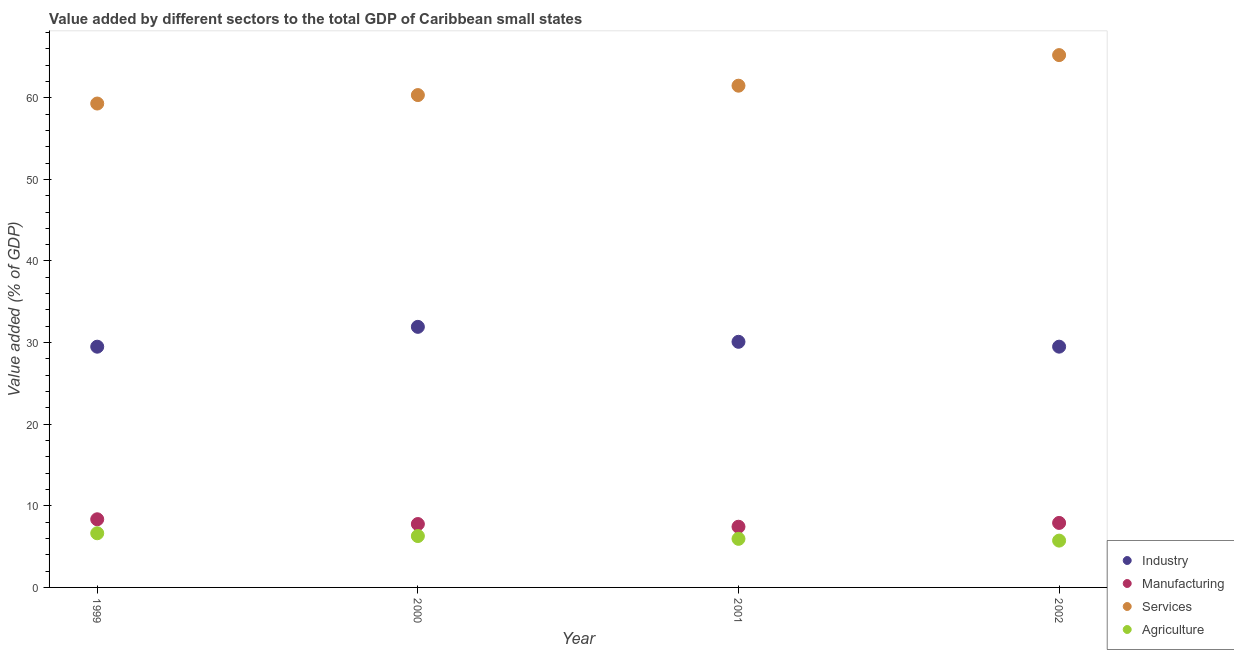How many different coloured dotlines are there?
Provide a short and direct response. 4. Is the number of dotlines equal to the number of legend labels?
Your answer should be very brief. Yes. What is the value added by industrial sector in 2001?
Make the answer very short. 30.1. Across all years, what is the maximum value added by manufacturing sector?
Ensure brevity in your answer.  8.35. Across all years, what is the minimum value added by manufacturing sector?
Provide a succinct answer. 7.44. What is the total value added by industrial sector in the graph?
Provide a short and direct response. 121.03. What is the difference between the value added by agricultural sector in 1999 and that in 2001?
Your response must be concise. 0.68. What is the difference between the value added by services sector in 2001 and the value added by agricultural sector in 1999?
Your answer should be very brief. 54.84. What is the average value added by services sector per year?
Your answer should be very brief. 61.58. In the year 1999, what is the difference between the value added by manufacturing sector and value added by industrial sector?
Your answer should be very brief. -21.15. In how many years, is the value added by agricultural sector greater than 46 %?
Offer a very short reply. 0. What is the ratio of the value added by services sector in 2000 to that in 2001?
Your answer should be very brief. 0.98. Is the value added by manufacturing sector in 2000 less than that in 2001?
Your response must be concise. No. Is the difference between the value added by manufacturing sector in 1999 and 2002 greater than the difference between the value added by industrial sector in 1999 and 2002?
Your answer should be very brief. Yes. What is the difference between the highest and the second highest value added by agricultural sector?
Offer a very short reply. 0.34. What is the difference between the highest and the lowest value added by agricultural sector?
Provide a short and direct response. 0.9. In how many years, is the value added by industrial sector greater than the average value added by industrial sector taken over all years?
Provide a succinct answer. 1. Is it the case that in every year, the sum of the value added by services sector and value added by agricultural sector is greater than the sum of value added by industrial sector and value added by manufacturing sector?
Your answer should be compact. Yes. Is the value added by services sector strictly greater than the value added by agricultural sector over the years?
Your answer should be very brief. Yes. Is the value added by agricultural sector strictly less than the value added by industrial sector over the years?
Your answer should be compact. Yes. How many dotlines are there?
Your answer should be compact. 4. Are the values on the major ticks of Y-axis written in scientific E-notation?
Your answer should be very brief. No. Does the graph contain any zero values?
Your answer should be very brief. No. Does the graph contain grids?
Your answer should be compact. No. What is the title of the graph?
Keep it short and to the point. Value added by different sectors to the total GDP of Caribbean small states. Does "Taxes on income" appear as one of the legend labels in the graph?
Your response must be concise. No. What is the label or title of the Y-axis?
Keep it short and to the point. Value added (% of GDP). What is the Value added (% of GDP) in Industry in 1999?
Your answer should be very brief. 29.5. What is the Value added (% of GDP) in Manufacturing in 1999?
Provide a short and direct response. 8.35. What is the Value added (% of GDP) in Services in 1999?
Keep it short and to the point. 59.29. What is the Value added (% of GDP) in Agriculture in 1999?
Your answer should be very brief. 6.64. What is the Value added (% of GDP) of Industry in 2000?
Your answer should be compact. 31.93. What is the Value added (% of GDP) in Manufacturing in 2000?
Your response must be concise. 7.77. What is the Value added (% of GDP) in Services in 2000?
Ensure brevity in your answer.  60.33. What is the Value added (% of GDP) of Agriculture in 2000?
Your answer should be compact. 6.3. What is the Value added (% of GDP) of Industry in 2001?
Your response must be concise. 30.1. What is the Value added (% of GDP) of Manufacturing in 2001?
Make the answer very short. 7.44. What is the Value added (% of GDP) of Services in 2001?
Provide a short and direct response. 61.48. What is the Value added (% of GDP) in Agriculture in 2001?
Make the answer very short. 5.95. What is the Value added (% of GDP) in Industry in 2002?
Offer a very short reply. 29.5. What is the Value added (% of GDP) of Manufacturing in 2002?
Your answer should be very brief. 7.9. What is the Value added (% of GDP) in Services in 2002?
Make the answer very short. 65.23. What is the Value added (% of GDP) in Agriculture in 2002?
Provide a short and direct response. 5.74. Across all years, what is the maximum Value added (% of GDP) of Industry?
Keep it short and to the point. 31.93. Across all years, what is the maximum Value added (% of GDP) in Manufacturing?
Keep it short and to the point. 8.35. Across all years, what is the maximum Value added (% of GDP) in Services?
Provide a succinct answer. 65.23. Across all years, what is the maximum Value added (% of GDP) in Agriculture?
Provide a succinct answer. 6.64. Across all years, what is the minimum Value added (% of GDP) in Industry?
Provide a short and direct response. 29.5. Across all years, what is the minimum Value added (% of GDP) in Manufacturing?
Provide a succinct answer. 7.44. Across all years, what is the minimum Value added (% of GDP) of Services?
Make the answer very short. 59.29. Across all years, what is the minimum Value added (% of GDP) of Agriculture?
Give a very brief answer. 5.74. What is the total Value added (% of GDP) of Industry in the graph?
Provide a succinct answer. 121.03. What is the total Value added (% of GDP) in Manufacturing in the graph?
Your response must be concise. 31.46. What is the total Value added (% of GDP) of Services in the graph?
Offer a very short reply. 246.33. What is the total Value added (% of GDP) of Agriculture in the graph?
Your answer should be compact. 24.62. What is the difference between the Value added (% of GDP) in Industry in 1999 and that in 2000?
Offer a very short reply. -2.43. What is the difference between the Value added (% of GDP) in Manufacturing in 1999 and that in 2000?
Make the answer very short. 0.58. What is the difference between the Value added (% of GDP) of Services in 1999 and that in 2000?
Provide a succinct answer. -1.04. What is the difference between the Value added (% of GDP) of Agriculture in 1999 and that in 2000?
Offer a terse response. 0.34. What is the difference between the Value added (% of GDP) in Industry in 1999 and that in 2001?
Offer a very short reply. -0.6. What is the difference between the Value added (% of GDP) in Manufacturing in 1999 and that in 2001?
Provide a short and direct response. 0.91. What is the difference between the Value added (% of GDP) of Services in 1999 and that in 2001?
Offer a very short reply. -2.19. What is the difference between the Value added (% of GDP) in Agriculture in 1999 and that in 2001?
Make the answer very short. 0.68. What is the difference between the Value added (% of GDP) in Industry in 1999 and that in 2002?
Your answer should be compact. -0. What is the difference between the Value added (% of GDP) of Manufacturing in 1999 and that in 2002?
Your answer should be very brief. 0.45. What is the difference between the Value added (% of GDP) of Services in 1999 and that in 2002?
Make the answer very short. -5.93. What is the difference between the Value added (% of GDP) in Agriculture in 1999 and that in 2002?
Your answer should be very brief. 0.9. What is the difference between the Value added (% of GDP) of Industry in 2000 and that in 2001?
Your response must be concise. 1.83. What is the difference between the Value added (% of GDP) of Manufacturing in 2000 and that in 2001?
Your answer should be compact. 0.33. What is the difference between the Value added (% of GDP) in Services in 2000 and that in 2001?
Offer a terse response. -1.15. What is the difference between the Value added (% of GDP) of Agriculture in 2000 and that in 2001?
Offer a terse response. 0.34. What is the difference between the Value added (% of GDP) in Industry in 2000 and that in 2002?
Your answer should be very brief. 2.43. What is the difference between the Value added (% of GDP) in Manufacturing in 2000 and that in 2002?
Provide a short and direct response. -0.14. What is the difference between the Value added (% of GDP) in Services in 2000 and that in 2002?
Give a very brief answer. -4.9. What is the difference between the Value added (% of GDP) of Agriculture in 2000 and that in 2002?
Your response must be concise. 0.56. What is the difference between the Value added (% of GDP) in Industry in 2001 and that in 2002?
Provide a succinct answer. 0.59. What is the difference between the Value added (% of GDP) in Manufacturing in 2001 and that in 2002?
Give a very brief answer. -0.47. What is the difference between the Value added (% of GDP) in Services in 2001 and that in 2002?
Offer a terse response. -3.75. What is the difference between the Value added (% of GDP) in Agriculture in 2001 and that in 2002?
Give a very brief answer. 0.22. What is the difference between the Value added (% of GDP) in Industry in 1999 and the Value added (% of GDP) in Manufacturing in 2000?
Ensure brevity in your answer.  21.73. What is the difference between the Value added (% of GDP) of Industry in 1999 and the Value added (% of GDP) of Services in 2000?
Your answer should be compact. -30.83. What is the difference between the Value added (% of GDP) of Industry in 1999 and the Value added (% of GDP) of Agriculture in 2000?
Offer a terse response. 23.2. What is the difference between the Value added (% of GDP) in Manufacturing in 1999 and the Value added (% of GDP) in Services in 2000?
Give a very brief answer. -51.98. What is the difference between the Value added (% of GDP) of Manufacturing in 1999 and the Value added (% of GDP) of Agriculture in 2000?
Keep it short and to the point. 2.06. What is the difference between the Value added (% of GDP) of Services in 1999 and the Value added (% of GDP) of Agriculture in 2000?
Your answer should be compact. 53. What is the difference between the Value added (% of GDP) in Industry in 1999 and the Value added (% of GDP) in Manufacturing in 2001?
Your answer should be very brief. 22.06. What is the difference between the Value added (% of GDP) in Industry in 1999 and the Value added (% of GDP) in Services in 2001?
Make the answer very short. -31.98. What is the difference between the Value added (% of GDP) in Industry in 1999 and the Value added (% of GDP) in Agriculture in 2001?
Offer a terse response. 23.55. What is the difference between the Value added (% of GDP) of Manufacturing in 1999 and the Value added (% of GDP) of Services in 2001?
Your answer should be compact. -53.13. What is the difference between the Value added (% of GDP) of Manufacturing in 1999 and the Value added (% of GDP) of Agriculture in 2001?
Offer a very short reply. 2.4. What is the difference between the Value added (% of GDP) of Services in 1999 and the Value added (% of GDP) of Agriculture in 2001?
Ensure brevity in your answer.  53.34. What is the difference between the Value added (% of GDP) of Industry in 1999 and the Value added (% of GDP) of Manufacturing in 2002?
Give a very brief answer. 21.59. What is the difference between the Value added (% of GDP) in Industry in 1999 and the Value added (% of GDP) in Services in 2002?
Offer a terse response. -35.73. What is the difference between the Value added (% of GDP) of Industry in 1999 and the Value added (% of GDP) of Agriculture in 2002?
Offer a very short reply. 23.76. What is the difference between the Value added (% of GDP) in Manufacturing in 1999 and the Value added (% of GDP) in Services in 2002?
Offer a very short reply. -56.88. What is the difference between the Value added (% of GDP) of Manufacturing in 1999 and the Value added (% of GDP) of Agriculture in 2002?
Your answer should be compact. 2.62. What is the difference between the Value added (% of GDP) of Services in 1999 and the Value added (% of GDP) of Agriculture in 2002?
Ensure brevity in your answer.  53.56. What is the difference between the Value added (% of GDP) in Industry in 2000 and the Value added (% of GDP) in Manufacturing in 2001?
Offer a very short reply. 24.49. What is the difference between the Value added (% of GDP) in Industry in 2000 and the Value added (% of GDP) in Services in 2001?
Make the answer very short. -29.55. What is the difference between the Value added (% of GDP) in Industry in 2000 and the Value added (% of GDP) in Agriculture in 2001?
Make the answer very short. 25.98. What is the difference between the Value added (% of GDP) in Manufacturing in 2000 and the Value added (% of GDP) in Services in 2001?
Give a very brief answer. -53.71. What is the difference between the Value added (% of GDP) in Manufacturing in 2000 and the Value added (% of GDP) in Agriculture in 2001?
Your answer should be very brief. 1.81. What is the difference between the Value added (% of GDP) in Services in 2000 and the Value added (% of GDP) in Agriculture in 2001?
Your answer should be very brief. 54.38. What is the difference between the Value added (% of GDP) in Industry in 2000 and the Value added (% of GDP) in Manufacturing in 2002?
Ensure brevity in your answer.  24.03. What is the difference between the Value added (% of GDP) in Industry in 2000 and the Value added (% of GDP) in Services in 2002?
Give a very brief answer. -33.3. What is the difference between the Value added (% of GDP) of Industry in 2000 and the Value added (% of GDP) of Agriculture in 2002?
Offer a terse response. 26.19. What is the difference between the Value added (% of GDP) of Manufacturing in 2000 and the Value added (% of GDP) of Services in 2002?
Offer a terse response. -57.46. What is the difference between the Value added (% of GDP) of Manufacturing in 2000 and the Value added (% of GDP) of Agriculture in 2002?
Offer a terse response. 2.03. What is the difference between the Value added (% of GDP) in Services in 2000 and the Value added (% of GDP) in Agriculture in 2002?
Provide a succinct answer. 54.59. What is the difference between the Value added (% of GDP) of Industry in 2001 and the Value added (% of GDP) of Manufacturing in 2002?
Offer a very short reply. 22.19. What is the difference between the Value added (% of GDP) in Industry in 2001 and the Value added (% of GDP) in Services in 2002?
Your answer should be very brief. -35.13. What is the difference between the Value added (% of GDP) of Industry in 2001 and the Value added (% of GDP) of Agriculture in 2002?
Your response must be concise. 24.36. What is the difference between the Value added (% of GDP) in Manufacturing in 2001 and the Value added (% of GDP) in Services in 2002?
Your answer should be compact. -57.79. What is the difference between the Value added (% of GDP) in Manufacturing in 2001 and the Value added (% of GDP) in Agriculture in 2002?
Give a very brief answer. 1.7. What is the difference between the Value added (% of GDP) in Services in 2001 and the Value added (% of GDP) in Agriculture in 2002?
Your response must be concise. 55.74. What is the average Value added (% of GDP) of Industry per year?
Offer a very short reply. 30.26. What is the average Value added (% of GDP) in Manufacturing per year?
Keep it short and to the point. 7.86. What is the average Value added (% of GDP) of Services per year?
Your response must be concise. 61.58. What is the average Value added (% of GDP) in Agriculture per year?
Offer a terse response. 6.16. In the year 1999, what is the difference between the Value added (% of GDP) of Industry and Value added (% of GDP) of Manufacturing?
Your answer should be very brief. 21.15. In the year 1999, what is the difference between the Value added (% of GDP) of Industry and Value added (% of GDP) of Services?
Your response must be concise. -29.79. In the year 1999, what is the difference between the Value added (% of GDP) in Industry and Value added (% of GDP) in Agriculture?
Your answer should be very brief. 22.86. In the year 1999, what is the difference between the Value added (% of GDP) in Manufacturing and Value added (% of GDP) in Services?
Your answer should be compact. -50.94. In the year 1999, what is the difference between the Value added (% of GDP) in Manufacturing and Value added (% of GDP) in Agriculture?
Provide a succinct answer. 1.71. In the year 1999, what is the difference between the Value added (% of GDP) of Services and Value added (% of GDP) of Agriculture?
Your response must be concise. 52.66. In the year 2000, what is the difference between the Value added (% of GDP) in Industry and Value added (% of GDP) in Manufacturing?
Keep it short and to the point. 24.16. In the year 2000, what is the difference between the Value added (% of GDP) in Industry and Value added (% of GDP) in Services?
Ensure brevity in your answer.  -28.4. In the year 2000, what is the difference between the Value added (% of GDP) in Industry and Value added (% of GDP) in Agriculture?
Provide a short and direct response. 25.63. In the year 2000, what is the difference between the Value added (% of GDP) of Manufacturing and Value added (% of GDP) of Services?
Ensure brevity in your answer.  -52.56. In the year 2000, what is the difference between the Value added (% of GDP) in Manufacturing and Value added (% of GDP) in Agriculture?
Provide a short and direct response. 1.47. In the year 2000, what is the difference between the Value added (% of GDP) of Services and Value added (% of GDP) of Agriculture?
Provide a short and direct response. 54.03. In the year 2001, what is the difference between the Value added (% of GDP) in Industry and Value added (% of GDP) in Manufacturing?
Give a very brief answer. 22.66. In the year 2001, what is the difference between the Value added (% of GDP) in Industry and Value added (% of GDP) in Services?
Keep it short and to the point. -31.38. In the year 2001, what is the difference between the Value added (% of GDP) in Industry and Value added (% of GDP) in Agriculture?
Offer a very short reply. 24.14. In the year 2001, what is the difference between the Value added (% of GDP) in Manufacturing and Value added (% of GDP) in Services?
Ensure brevity in your answer.  -54.04. In the year 2001, what is the difference between the Value added (% of GDP) of Manufacturing and Value added (% of GDP) of Agriculture?
Your answer should be compact. 1.48. In the year 2001, what is the difference between the Value added (% of GDP) of Services and Value added (% of GDP) of Agriculture?
Keep it short and to the point. 55.53. In the year 2002, what is the difference between the Value added (% of GDP) of Industry and Value added (% of GDP) of Manufacturing?
Your answer should be very brief. 21.6. In the year 2002, what is the difference between the Value added (% of GDP) in Industry and Value added (% of GDP) in Services?
Offer a terse response. -35.73. In the year 2002, what is the difference between the Value added (% of GDP) of Industry and Value added (% of GDP) of Agriculture?
Offer a terse response. 23.77. In the year 2002, what is the difference between the Value added (% of GDP) in Manufacturing and Value added (% of GDP) in Services?
Provide a succinct answer. -57.32. In the year 2002, what is the difference between the Value added (% of GDP) in Manufacturing and Value added (% of GDP) in Agriculture?
Offer a very short reply. 2.17. In the year 2002, what is the difference between the Value added (% of GDP) of Services and Value added (% of GDP) of Agriculture?
Keep it short and to the point. 59.49. What is the ratio of the Value added (% of GDP) in Industry in 1999 to that in 2000?
Your answer should be very brief. 0.92. What is the ratio of the Value added (% of GDP) of Manufacturing in 1999 to that in 2000?
Provide a succinct answer. 1.08. What is the ratio of the Value added (% of GDP) of Services in 1999 to that in 2000?
Offer a terse response. 0.98. What is the ratio of the Value added (% of GDP) of Agriculture in 1999 to that in 2000?
Provide a short and direct response. 1.05. What is the ratio of the Value added (% of GDP) in Industry in 1999 to that in 2001?
Your answer should be very brief. 0.98. What is the ratio of the Value added (% of GDP) in Manufacturing in 1999 to that in 2001?
Offer a very short reply. 1.12. What is the ratio of the Value added (% of GDP) in Services in 1999 to that in 2001?
Keep it short and to the point. 0.96. What is the ratio of the Value added (% of GDP) in Agriculture in 1999 to that in 2001?
Your answer should be compact. 1.11. What is the ratio of the Value added (% of GDP) of Industry in 1999 to that in 2002?
Make the answer very short. 1. What is the ratio of the Value added (% of GDP) of Manufacturing in 1999 to that in 2002?
Provide a short and direct response. 1.06. What is the ratio of the Value added (% of GDP) of Services in 1999 to that in 2002?
Provide a short and direct response. 0.91. What is the ratio of the Value added (% of GDP) in Agriculture in 1999 to that in 2002?
Your response must be concise. 1.16. What is the ratio of the Value added (% of GDP) of Industry in 2000 to that in 2001?
Your answer should be very brief. 1.06. What is the ratio of the Value added (% of GDP) in Manufacturing in 2000 to that in 2001?
Offer a very short reply. 1.04. What is the ratio of the Value added (% of GDP) in Services in 2000 to that in 2001?
Keep it short and to the point. 0.98. What is the ratio of the Value added (% of GDP) in Agriculture in 2000 to that in 2001?
Ensure brevity in your answer.  1.06. What is the ratio of the Value added (% of GDP) of Industry in 2000 to that in 2002?
Your answer should be very brief. 1.08. What is the ratio of the Value added (% of GDP) in Manufacturing in 2000 to that in 2002?
Your answer should be very brief. 0.98. What is the ratio of the Value added (% of GDP) in Services in 2000 to that in 2002?
Your answer should be very brief. 0.92. What is the ratio of the Value added (% of GDP) of Agriculture in 2000 to that in 2002?
Offer a very short reply. 1.1. What is the ratio of the Value added (% of GDP) in Industry in 2001 to that in 2002?
Offer a terse response. 1.02. What is the ratio of the Value added (% of GDP) in Manufacturing in 2001 to that in 2002?
Your response must be concise. 0.94. What is the ratio of the Value added (% of GDP) of Services in 2001 to that in 2002?
Make the answer very short. 0.94. What is the ratio of the Value added (% of GDP) in Agriculture in 2001 to that in 2002?
Provide a short and direct response. 1.04. What is the difference between the highest and the second highest Value added (% of GDP) of Industry?
Your answer should be very brief. 1.83. What is the difference between the highest and the second highest Value added (% of GDP) of Manufacturing?
Provide a short and direct response. 0.45. What is the difference between the highest and the second highest Value added (% of GDP) of Services?
Offer a very short reply. 3.75. What is the difference between the highest and the second highest Value added (% of GDP) of Agriculture?
Offer a terse response. 0.34. What is the difference between the highest and the lowest Value added (% of GDP) of Industry?
Ensure brevity in your answer.  2.43. What is the difference between the highest and the lowest Value added (% of GDP) in Manufacturing?
Ensure brevity in your answer.  0.91. What is the difference between the highest and the lowest Value added (% of GDP) of Services?
Give a very brief answer. 5.93. What is the difference between the highest and the lowest Value added (% of GDP) in Agriculture?
Your response must be concise. 0.9. 